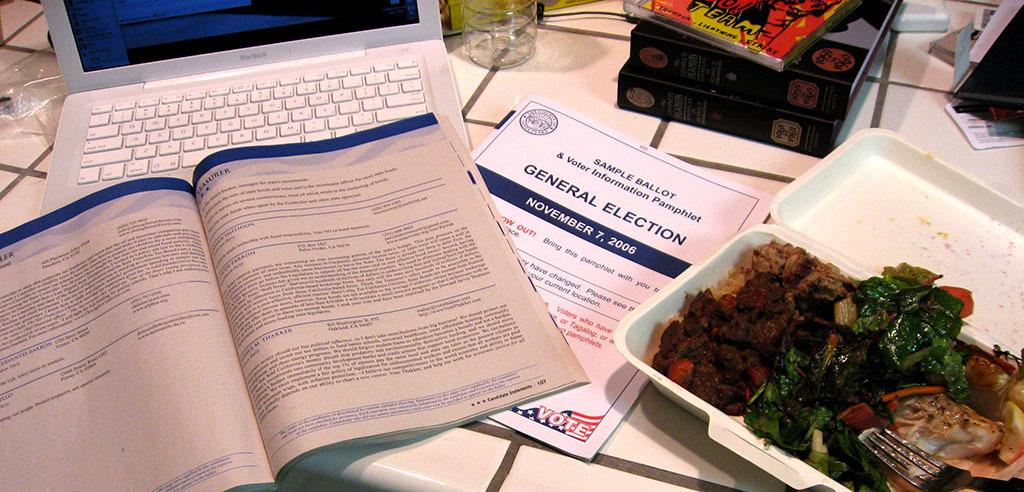<image>
Render a clear and concise summary of the photo. Someone is eating takeout food and looking at a sample ballot for the general election in 2006. 